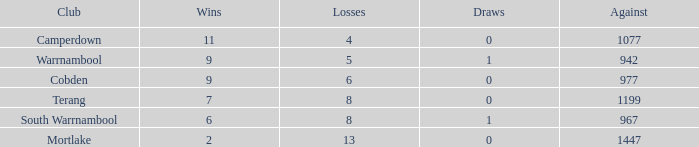I'm looking to parse the entire table for insights. Could you assist me with that? {'header': ['Club', 'Wins', 'Losses', 'Draws', 'Against'], 'rows': [['Camperdown', '11', '4', '0', '1077'], ['Warrnambool', '9', '5', '1', '942'], ['Cobden', '9', '6', '0', '977'], ['Terang', '7', '8', '0', '1199'], ['South Warrnambool', '6', '8', '1', '967'], ['Mortlake', '2', '13', '0', '1447']]} How many ties did mortlake have when the defeats exceeded 5? 1.0. 